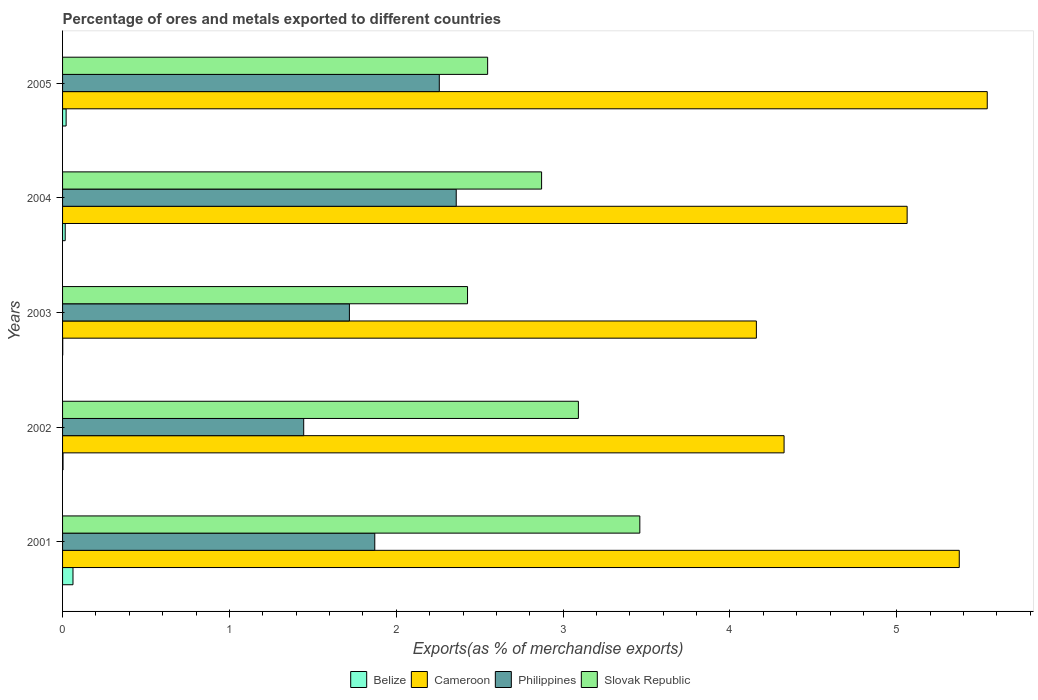How many different coloured bars are there?
Your answer should be very brief. 4. Are the number of bars per tick equal to the number of legend labels?
Provide a short and direct response. Yes. Are the number of bars on each tick of the Y-axis equal?
Your response must be concise. Yes. How many bars are there on the 5th tick from the top?
Ensure brevity in your answer.  4. What is the label of the 3rd group of bars from the top?
Offer a terse response. 2003. In how many cases, is the number of bars for a given year not equal to the number of legend labels?
Keep it short and to the point. 0. What is the percentage of exports to different countries in Cameroon in 2001?
Provide a short and direct response. 5.37. Across all years, what is the maximum percentage of exports to different countries in Philippines?
Your answer should be compact. 2.36. Across all years, what is the minimum percentage of exports to different countries in Cameroon?
Ensure brevity in your answer.  4.16. In which year was the percentage of exports to different countries in Philippines maximum?
Keep it short and to the point. 2004. What is the total percentage of exports to different countries in Philippines in the graph?
Provide a succinct answer. 9.65. What is the difference between the percentage of exports to different countries in Cameroon in 2001 and that in 2004?
Your answer should be compact. 0.31. What is the difference between the percentage of exports to different countries in Cameroon in 2004 and the percentage of exports to different countries in Philippines in 2001?
Offer a terse response. 3.19. What is the average percentage of exports to different countries in Cameroon per year?
Offer a terse response. 4.89. In the year 2004, what is the difference between the percentage of exports to different countries in Philippines and percentage of exports to different countries in Slovak Republic?
Offer a terse response. -0.51. In how many years, is the percentage of exports to different countries in Belize greater than 1.2 %?
Your response must be concise. 0. What is the ratio of the percentage of exports to different countries in Slovak Republic in 2001 to that in 2002?
Your answer should be very brief. 1.12. What is the difference between the highest and the second highest percentage of exports to different countries in Cameroon?
Ensure brevity in your answer.  0.17. What is the difference between the highest and the lowest percentage of exports to different countries in Belize?
Give a very brief answer. 0.06. In how many years, is the percentage of exports to different countries in Slovak Republic greater than the average percentage of exports to different countries in Slovak Republic taken over all years?
Make the answer very short. 2. Is it the case that in every year, the sum of the percentage of exports to different countries in Philippines and percentage of exports to different countries in Cameroon is greater than the sum of percentage of exports to different countries in Slovak Republic and percentage of exports to different countries in Belize?
Offer a terse response. No. What does the 4th bar from the top in 2005 represents?
Provide a succinct answer. Belize. What does the 3rd bar from the bottom in 2005 represents?
Provide a succinct answer. Philippines. Is it the case that in every year, the sum of the percentage of exports to different countries in Cameroon and percentage of exports to different countries in Philippines is greater than the percentage of exports to different countries in Slovak Republic?
Offer a terse response. Yes. Are all the bars in the graph horizontal?
Offer a terse response. Yes. How many years are there in the graph?
Make the answer very short. 5. What is the difference between two consecutive major ticks on the X-axis?
Offer a very short reply. 1. Does the graph contain any zero values?
Ensure brevity in your answer.  No. Where does the legend appear in the graph?
Ensure brevity in your answer.  Bottom center. How many legend labels are there?
Your answer should be compact. 4. How are the legend labels stacked?
Keep it short and to the point. Horizontal. What is the title of the graph?
Make the answer very short. Percentage of ores and metals exported to different countries. What is the label or title of the X-axis?
Give a very brief answer. Exports(as % of merchandise exports). What is the label or title of the Y-axis?
Give a very brief answer. Years. What is the Exports(as % of merchandise exports) in Belize in 2001?
Your response must be concise. 0.06. What is the Exports(as % of merchandise exports) of Cameroon in 2001?
Keep it short and to the point. 5.37. What is the Exports(as % of merchandise exports) of Philippines in 2001?
Give a very brief answer. 1.87. What is the Exports(as % of merchandise exports) of Slovak Republic in 2001?
Your response must be concise. 3.46. What is the Exports(as % of merchandise exports) of Belize in 2002?
Ensure brevity in your answer.  0. What is the Exports(as % of merchandise exports) of Cameroon in 2002?
Make the answer very short. 4.32. What is the Exports(as % of merchandise exports) of Philippines in 2002?
Offer a terse response. 1.45. What is the Exports(as % of merchandise exports) of Slovak Republic in 2002?
Your answer should be very brief. 3.09. What is the Exports(as % of merchandise exports) in Belize in 2003?
Ensure brevity in your answer.  0. What is the Exports(as % of merchandise exports) of Cameroon in 2003?
Give a very brief answer. 4.16. What is the Exports(as % of merchandise exports) in Philippines in 2003?
Your answer should be very brief. 1.72. What is the Exports(as % of merchandise exports) of Slovak Republic in 2003?
Offer a very short reply. 2.43. What is the Exports(as % of merchandise exports) of Belize in 2004?
Your response must be concise. 0.02. What is the Exports(as % of merchandise exports) in Cameroon in 2004?
Your answer should be very brief. 5.06. What is the Exports(as % of merchandise exports) of Philippines in 2004?
Offer a terse response. 2.36. What is the Exports(as % of merchandise exports) of Slovak Republic in 2004?
Offer a very short reply. 2.87. What is the Exports(as % of merchandise exports) of Belize in 2005?
Make the answer very short. 0.02. What is the Exports(as % of merchandise exports) of Cameroon in 2005?
Offer a very short reply. 5.54. What is the Exports(as % of merchandise exports) in Philippines in 2005?
Provide a short and direct response. 2.26. What is the Exports(as % of merchandise exports) in Slovak Republic in 2005?
Offer a very short reply. 2.55. Across all years, what is the maximum Exports(as % of merchandise exports) in Belize?
Ensure brevity in your answer.  0.06. Across all years, what is the maximum Exports(as % of merchandise exports) of Cameroon?
Keep it short and to the point. 5.54. Across all years, what is the maximum Exports(as % of merchandise exports) of Philippines?
Provide a short and direct response. 2.36. Across all years, what is the maximum Exports(as % of merchandise exports) in Slovak Republic?
Make the answer very short. 3.46. Across all years, what is the minimum Exports(as % of merchandise exports) in Belize?
Provide a short and direct response. 0. Across all years, what is the minimum Exports(as % of merchandise exports) in Cameroon?
Give a very brief answer. 4.16. Across all years, what is the minimum Exports(as % of merchandise exports) of Philippines?
Your answer should be compact. 1.45. Across all years, what is the minimum Exports(as % of merchandise exports) of Slovak Republic?
Give a very brief answer. 2.43. What is the total Exports(as % of merchandise exports) in Belize in the graph?
Offer a very short reply. 0.1. What is the total Exports(as % of merchandise exports) of Cameroon in the graph?
Your answer should be very brief. 24.46. What is the total Exports(as % of merchandise exports) of Philippines in the graph?
Provide a succinct answer. 9.65. What is the total Exports(as % of merchandise exports) in Slovak Republic in the graph?
Your answer should be very brief. 14.4. What is the difference between the Exports(as % of merchandise exports) in Belize in 2001 and that in 2002?
Offer a terse response. 0.06. What is the difference between the Exports(as % of merchandise exports) in Philippines in 2001 and that in 2002?
Offer a very short reply. 0.43. What is the difference between the Exports(as % of merchandise exports) of Slovak Republic in 2001 and that in 2002?
Offer a terse response. 0.37. What is the difference between the Exports(as % of merchandise exports) of Belize in 2001 and that in 2003?
Offer a terse response. 0.06. What is the difference between the Exports(as % of merchandise exports) of Cameroon in 2001 and that in 2003?
Give a very brief answer. 1.22. What is the difference between the Exports(as % of merchandise exports) of Philippines in 2001 and that in 2003?
Provide a succinct answer. 0.15. What is the difference between the Exports(as % of merchandise exports) of Slovak Republic in 2001 and that in 2003?
Give a very brief answer. 1.03. What is the difference between the Exports(as % of merchandise exports) of Belize in 2001 and that in 2004?
Give a very brief answer. 0.05. What is the difference between the Exports(as % of merchandise exports) in Cameroon in 2001 and that in 2004?
Provide a short and direct response. 0.31. What is the difference between the Exports(as % of merchandise exports) of Philippines in 2001 and that in 2004?
Your response must be concise. -0.49. What is the difference between the Exports(as % of merchandise exports) in Slovak Republic in 2001 and that in 2004?
Your response must be concise. 0.59. What is the difference between the Exports(as % of merchandise exports) in Belize in 2001 and that in 2005?
Provide a short and direct response. 0.04. What is the difference between the Exports(as % of merchandise exports) in Cameroon in 2001 and that in 2005?
Offer a very short reply. -0.17. What is the difference between the Exports(as % of merchandise exports) of Philippines in 2001 and that in 2005?
Make the answer very short. -0.39. What is the difference between the Exports(as % of merchandise exports) of Slovak Republic in 2001 and that in 2005?
Your answer should be compact. 0.91. What is the difference between the Exports(as % of merchandise exports) of Belize in 2002 and that in 2003?
Provide a succinct answer. 0. What is the difference between the Exports(as % of merchandise exports) of Cameroon in 2002 and that in 2003?
Provide a short and direct response. 0.17. What is the difference between the Exports(as % of merchandise exports) of Philippines in 2002 and that in 2003?
Provide a short and direct response. -0.27. What is the difference between the Exports(as % of merchandise exports) of Slovak Republic in 2002 and that in 2003?
Your answer should be very brief. 0.66. What is the difference between the Exports(as % of merchandise exports) of Belize in 2002 and that in 2004?
Your answer should be very brief. -0.01. What is the difference between the Exports(as % of merchandise exports) in Cameroon in 2002 and that in 2004?
Keep it short and to the point. -0.74. What is the difference between the Exports(as % of merchandise exports) of Philippines in 2002 and that in 2004?
Offer a terse response. -0.91. What is the difference between the Exports(as % of merchandise exports) in Slovak Republic in 2002 and that in 2004?
Your response must be concise. 0.22. What is the difference between the Exports(as % of merchandise exports) in Belize in 2002 and that in 2005?
Your response must be concise. -0.02. What is the difference between the Exports(as % of merchandise exports) of Cameroon in 2002 and that in 2005?
Give a very brief answer. -1.22. What is the difference between the Exports(as % of merchandise exports) of Philippines in 2002 and that in 2005?
Offer a very short reply. -0.81. What is the difference between the Exports(as % of merchandise exports) of Slovak Republic in 2002 and that in 2005?
Your response must be concise. 0.54. What is the difference between the Exports(as % of merchandise exports) in Belize in 2003 and that in 2004?
Provide a succinct answer. -0.01. What is the difference between the Exports(as % of merchandise exports) in Cameroon in 2003 and that in 2004?
Your answer should be very brief. -0.9. What is the difference between the Exports(as % of merchandise exports) of Philippines in 2003 and that in 2004?
Your answer should be compact. -0.64. What is the difference between the Exports(as % of merchandise exports) in Slovak Republic in 2003 and that in 2004?
Provide a succinct answer. -0.44. What is the difference between the Exports(as % of merchandise exports) of Belize in 2003 and that in 2005?
Your answer should be compact. -0.02. What is the difference between the Exports(as % of merchandise exports) in Cameroon in 2003 and that in 2005?
Keep it short and to the point. -1.38. What is the difference between the Exports(as % of merchandise exports) in Philippines in 2003 and that in 2005?
Keep it short and to the point. -0.54. What is the difference between the Exports(as % of merchandise exports) of Slovak Republic in 2003 and that in 2005?
Make the answer very short. -0.12. What is the difference between the Exports(as % of merchandise exports) of Belize in 2004 and that in 2005?
Give a very brief answer. -0.01. What is the difference between the Exports(as % of merchandise exports) of Cameroon in 2004 and that in 2005?
Provide a short and direct response. -0.48. What is the difference between the Exports(as % of merchandise exports) of Philippines in 2004 and that in 2005?
Make the answer very short. 0.1. What is the difference between the Exports(as % of merchandise exports) of Slovak Republic in 2004 and that in 2005?
Offer a very short reply. 0.32. What is the difference between the Exports(as % of merchandise exports) of Belize in 2001 and the Exports(as % of merchandise exports) of Cameroon in 2002?
Make the answer very short. -4.26. What is the difference between the Exports(as % of merchandise exports) in Belize in 2001 and the Exports(as % of merchandise exports) in Philippines in 2002?
Your answer should be very brief. -1.38. What is the difference between the Exports(as % of merchandise exports) in Belize in 2001 and the Exports(as % of merchandise exports) in Slovak Republic in 2002?
Offer a very short reply. -3.03. What is the difference between the Exports(as % of merchandise exports) of Cameroon in 2001 and the Exports(as % of merchandise exports) of Philippines in 2002?
Provide a succinct answer. 3.93. What is the difference between the Exports(as % of merchandise exports) of Cameroon in 2001 and the Exports(as % of merchandise exports) of Slovak Republic in 2002?
Give a very brief answer. 2.28. What is the difference between the Exports(as % of merchandise exports) of Philippines in 2001 and the Exports(as % of merchandise exports) of Slovak Republic in 2002?
Ensure brevity in your answer.  -1.22. What is the difference between the Exports(as % of merchandise exports) of Belize in 2001 and the Exports(as % of merchandise exports) of Cameroon in 2003?
Keep it short and to the point. -4.1. What is the difference between the Exports(as % of merchandise exports) of Belize in 2001 and the Exports(as % of merchandise exports) of Philippines in 2003?
Provide a succinct answer. -1.66. What is the difference between the Exports(as % of merchandise exports) in Belize in 2001 and the Exports(as % of merchandise exports) in Slovak Republic in 2003?
Offer a terse response. -2.36. What is the difference between the Exports(as % of merchandise exports) of Cameroon in 2001 and the Exports(as % of merchandise exports) of Philippines in 2003?
Offer a terse response. 3.66. What is the difference between the Exports(as % of merchandise exports) of Cameroon in 2001 and the Exports(as % of merchandise exports) of Slovak Republic in 2003?
Give a very brief answer. 2.95. What is the difference between the Exports(as % of merchandise exports) of Philippines in 2001 and the Exports(as % of merchandise exports) of Slovak Republic in 2003?
Keep it short and to the point. -0.56. What is the difference between the Exports(as % of merchandise exports) of Belize in 2001 and the Exports(as % of merchandise exports) of Cameroon in 2004?
Your answer should be compact. -5. What is the difference between the Exports(as % of merchandise exports) in Belize in 2001 and the Exports(as % of merchandise exports) in Philippines in 2004?
Provide a succinct answer. -2.3. What is the difference between the Exports(as % of merchandise exports) of Belize in 2001 and the Exports(as % of merchandise exports) of Slovak Republic in 2004?
Your response must be concise. -2.81. What is the difference between the Exports(as % of merchandise exports) of Cameroon in 2001 and the Exports(as % of merchandise exports) of Philippines in 2004?
Give a very brief answer. 3.01. What is the difference between the Exports(as % of merchandise exports) of Cameroon in 2001 and the Exports(as % of merchandise exports) of Slovak Republic in 2004?
Your answer should be very brief. 2.5. What is the difference between the Exports(as % of merchandise exports) in Philippines in 2001 and the Exports(as % of merchandise exports) in Slovak Republic in 2004?
Offer a very short reply. -1. What is the difference between the Exports(as % of merchandise exports) in Belize in 2001 and the Exports(as % of merchandise exports) in Cameroon in 2005?
Offer a very short reply. -5.48. What is the difference between the Exports(as % of merchandise exports) in Belize in 2001 and the Exports(as % of merchandise exports) in Philippines in 2005?
Offer a terse response. -2.2. What is the difference between the Exports(as % of merchandise exports) of Belize in 2001 and the Exports(as % of merchandise exports) of Slovak Republic in 2005?
Your response must be concise. -2.49. What is the difference between the Exports(as % of merchandise exports) of Cameroon in 2001 and the Exports(as % of merchandise exports) of Philippines in 2005?
Offer a terse response. 3.12. What is the difference between the Exports(as % of merchandise exports) of Cameroon in 2001 and the Exports(as % of merchandise exports) of Slovak Republic in 2005?
Offer a terse response. 2.83. What is the difference between the Exports(as % of merchandise exports) of Philippines in 2001 and the Exports(as % of merchandise exports) of Slovak Republic in 2005?
Ensure brevity in your answer.  -0.68. What is the difference between the Exports(as % of merchandise exports) in Belize in 2002 and the Exports(as % of merchandise exports) in Cameroon in 2003?
Offer a very short reply. -4.16. What is the difference between the Exports(as % of merchandise exports) in Belize in 2002 and the Exports(as % of merchandise exports) in Philippines in 2003?
Give a very brief answer. -1.72. What is the difference between the Exports(as % of merchandise exports) in Belize in 2002 and the Exports(as % of merchandise exports) in Slovak Republic in 2003?
Keep it short and to the point. -2.42. What is the difference between the Exports(as % of merchandise exports) in Cameroon in 2002 and the Exports(as % of merchandise exports) in Philippines in 2003?
Offer a terse response. 2.61. What is the difference between the Exports(as % of merchandise exports) of Cameroon in 2002 and the Exports(as % of merchandise exports) of Slovak Republic in 2003?
Make the answer very short. 1.9. What is the difference between the Exports(as % of merchandise exports) in Philippines in 2002 and the Exports(as % of merchandise exports) in Slovak Republic in 2003?
Ensure brevity in your answer.  -0.98. What is the difference between the Exports(as % of merchandise exports) in Belize in 2002 and the Exports(as % of merchandise exports) in Cameroon in 2004?
Your answer should be very brief. -5.06. What is the difference between the Exports(as % of merchandise exports) of Belize in 2002 and the Exports(as % of merchandise exports) of Philippines in 2004?
Ensure brevity in your answer.  -2.36. What is the difference between the Exports(as % of merchandise exports) of Belize in 2002 and the Exports(as % of merchandise exports) of Slovak Republic in 2004?
Make the answer very short. -2.87. What is the difference between the Exports(as % of merchandise exports) in Cameroon in 2002 and the Exports(as % of merchandise exports) in Philippines in 2004?
Give a very brief answer. 1.96. What is the difference between the Exports(as % of merchandise exports) in Cameroon in 2002 and the Exports(as % of merchandise exports) in Slovak Republic in 2004?
Offer a very short reply. 1.45. What is the difference between the Exports(as % of merchandise exports) in Philippines in 2002 and the Exports(as % of merchandise exports) in Slovak Republic in 2004?
Your answer should be very brief. -1.43. What is the difference between the Exports(as % of merchandise exports) of Belize in 2002 and the Exports(as % of merchandise exports) of Cameroon in 2005?
Provide a succinct answer. -5.54. What is the difference between the Exports(as % of merchandise exports) in Belize in 2002 and the Exports(as % of merchandise exports) in Philippines in 2005?
Keep it short and to the point. -2.26. What is the difference between the Exports(as % of merchandise exports) in Belize in 2002 and the Exports(as % of merchandise exports) in Slovak Republic in 2005?
Your response must be concise. -2.54. What is the difference between the Exports(as % of merchandise exports) of Cameroon in 2002 and the Exports(as % of merchandise exports) of Philippines in 2005?
Provide a succinct answer. 2.07. What is the difference between the Exports(as % of merchandise exports) of Cameroon in 2002 and the Exports(as % of merchandise exports) of Slovak Republic in 2005?
Offer a terse response. 1.78. What is the difference between the Exports(as % of merchandise exports) of Philippines in 2002 and the Exports(as % of merchandise exports) of Slovak Republic in 2005?
Your answer should be compact. -1.1. What is the difference between the Exports(as % of merchandise exports) of Belize in 2003 and the Exports(as % of merchandise exports) of Cameroon in 2004?
Your answer should be very brief. -5.06. What is the difference between the Exports(as % of merchandise exports) of Belize in 2003 and the Exports(as % of merchandise exports) of Philippines in 2004?
Provide a succinct answer. -2.36. What is the difference between the Exports(as % of merchandise exports) of Belize in 2003 and the Exports(as % of merchandise exports) of Slovak Republic in 2004?
Offer a terse response. -2.87. What is the difference between the Exports(as % of merchandise exports) of Cameroon in 2003 and the Exports(as % of merchandise exports) of Philippines in 2004?
Make the answer very short. 1.8. What is the difference between the Exports(as % of merchandise exports) in Cameroon in 2003 and the Exports(as % of merchandise exports) in Slovak Republic in 2004?
Offer a terse response. 1.29. What is the difference between the Exports(as % of merchandise exports) in Philippines in 2003 and the Exports(as % of merchandise exports) in Slovak Republic in 2004?
Your answer should be very brief. -1.15. What is the difference between the Exports(as % of merchandise exports) of Belize in 2003 and the Exports(as % of merchandise exports) of Cameroon in 2005?
Your response must be concise. -5.54. What is the difference between the Exports(as % of merchandise exports) of Belize in 2003 and the Exports(as % of merchandise exports) of Philippines in 2005?
Offer a terse response. -2.26. What is the difference between the Exports(as % of merchandise exports) of Belize in 2003 and the Exports(as % of merchandise exports) of Slovak Republic in 2005?
Keep it short and to the point. -2.55. What is the difference between the Exports(as % of merchandise exports) of Cameroon in 2003 and the Exports(as % of merchandise exports) of Philippines in 2005?
Your answer should be very brief. 1.9. What is the difference between the Exports(as % of merchandise exports) in Cameroon in 2003 and the Exports(as % of merchandise exports) in Slovak Republic in 2005?
Give a very brief answer. 1.61. What is the difference between the Exports(as % of merchandise exports) of Philippines in 2003 and the Exports(as % of merchandise exports) of Slovak Republic in 2005?
Provide a short and direct response. -0.83. What is the difference between the Exports(as % of merchandise exports) in Belize in 2004 and the Exports(as % of merchandise exports) in Cameroon in 2005?
Your answer should be very brief. -5.53. What is the difference between the Exports(as % of merchandise exports) of Belize in 2004 and the Exports(as % of merchandise exports) of Philippines in 2005?
Make the answer very short. -2.24. What is the difference between the Exports(as % of merchandise exports) of Belize in 2004 and the Exports(as % of merchandise exports) of Slovak Republic in 2005?
Your response must be concise. -2.53. What is the difference between the Exports(as % of merchandise exports) of Cameroon in 2004 and the Exports(as % of merchandise exports) of Philippines in 2005?
Your answer should be very brief. 2.8. What is the difference between the Exports(as % of merchandise exports) of Cameroon in 2004 and the Exports(as % of merchandise exports) of Slovak Republic in 2005?
Offer a very short reply. 2.51. What is the difference between the Exports(as % of merchandise exports) in Philippines in 2004 and the Exports(as % of merchandise exports) in Slovak Republic in 2005?
Offer a very short reply. -0.19. What is the average Exports(as % of merchandise exports) in Belize per year?
Your answer should be very brief. 0.02. What is the average Exports(as % of merchandise exports) in Cameroon per year?
Make the answer very short. 4.89. What is the average Exports(as % of merchandise exports) of Philippines per year?
Provide a short and direct response. 1.93. What is the average Exports(as % of merchandise exports) in Slovak Republic per year?
Keep it short and to the point. 2.88. In the year 2001, what is the difference between the Exports(as % of merchandise exports) in Belize and Exports(as % of merchandise exports) in Cameroon?
Keep it short and to the point. -5.31. In the year 2001, what is the difference between the Exports(as % of merchandise exports) in Belize and Exports(as % of merchandise exports) in Philippines?
Your answer should be compact. -1.81. In the year 2001, what is the difference between the Exports(as % of merchandise exports) of Belize and Exports(as % of merchandise exports) of Slovak Republic?
Keep it short and to the point. -3.4. In the year 2001, what is the difference between the Exports(as % of merchandise exports) of Cameroon and Exports(as % of merchandise exports) of Philippines?
Your answer should be very brief. 3.5. In the year 2001, what is the difference between the Exports(as % of merchandise exports) in Cameroon and Exports(as % of merchandise exports) in Slovak Republic?
Provide a succinct answer. 1.91. In the year 2001, what is the difference between the Exports(as % of merchandise exports) in Philippines and Exports(as % of merchandise exports) in Slovak Republic?
Your answer should be compact. -1.59. In the year 2002, what is the difference between the Exports(as % of merchandise exports) of Belize and Exports(as % of merchandise exports) of Cameroon?
Give a very brief answer. -4.32. In the year 2002, what is the difference between the Exports(as % of merchandise exports) in Belize and Exports(as % of merchandise exports) in Philippines?
Offer a very short reply. -1.44. In the year 2002, what is the difference between the Exports(as % of merchandise exports) of Belize and Exports(as % of merchandise exports) of Slovak Republic?
Make the answer very short. -3.09. In the year 2002, what is the difference between the Exports(as % of merchandise exports) in Cameroon and Exports(as % of merchandise exports) in Philippines?
Offer a terse response. 2.88. In the year 2002, what is the difference between the Exports(as % of merchandise exports) in Cameroon and Exports(as % of merchandise exports) in Slovak Republic?
Offer a very short reply. 1.23. In the year 2002, what is the difference between the Exports(as % of merchandise exports) of Philippines and Exports(as % of merchandise exports) of Slovak Republic?
Your response must be concise. -1.65. In the year 2003, what is the difference between the Exports(as % of merchandise exports) of Belize and Exports(as % of merchandise exports) of Cameroon?
Your answer should be compact. -4.16. In the year 2003, what is the difference between the Exports(as % of merchandise exports) of Belize and Exports(as % of merchandise exports) of Philippines?
Your answer should be very brief. -1.72. In the year 2003, what is the difference between the Exports(as % of merchandise exports) in Belize and Exports(as % of merchandise exports) in Slovak Republic?
Provide a short and direct response. -2.43. In the year 2003, what is the difference between the Exports(as % of merchandise exports) of Cameroon and Exports(as % of merchandise exports) of Philippines?
Make the answer very short. 2.44. In the year 2003, what is the difference between the Exports(as % of merchandise exports) in Cameroon and Exports(as % of merchandise exports) in Slovak Republic?
Ensure brevity in your answer.  1.73. In the year 2003, what is the difference between the Exports(as % of merchandise exports) in Philippines and Exports(as % of merchandise exports) in Slovak Republic?
Offer a very short reply. -0.71. In the year 2004, what is the difference between the Exports(as % of merchandise exports) in Belize and Exports(as % of merchandise exports) in Cameroon?
Provide a succinct answer. -5.05. In the year 2004, what is the difference between the Exports(as % of merchandise exports) in Belize and Exports(as % of merchandise exports) in Philippines?
Provide a short and direct response. -2.34. In the year 2004, what is the difference between the Exports(as % of merchandise exports) in Belize and Exports(as % of merchandise exports) in Slovak Republic?
Offer a very short reply. -2.86. In the year 2004, what is the difference between the Exports(as % of merchandise exports) in Cameroon and Exports(as % of merchandise exports) in Philippines?
Provide a short and direct response. 2.7. In the year 2004, what is the difference between the Exports(as % of merchandise exports) in Cameroon and Exports(as % of merchandise exports) in Slovak Republic?
Your answer should be very brief. 2.19. In the year 2004, what is the difference between the Exports(as % of merchandise exports) in Philippines and Exports(as % of merchandise exports) in Slovak Republic?
Make the answer very short. -0.51. In the year 2005, what is the difference between the Exports(as % of merchandise exports) of Belize and Exports(as % of merchandise exports) of Cameroon?
Your response must be concise. -5.52. In the year 2005, what is the difference between the Exports(as % of merchandise exports) in Belize and Exports(as % of merchandise exports) in Philippines?
Keep it short and to the point. -2.24. In the year 2005, what is the difference between the Exports(as % of merchandise exports) of Belize and Exports(as % of merchandise exports) of Slovak Republic?
Your answer should be very brief. -2.53. In the year 2005, what is the difference between the Exports(as % of merchandise exports) of Cameroon and Exports(as % of merchandise exports) of Philippines?
Offer a terse response. 3.28. In the year 2005, what is the difference between the Exports(as % of merchandise exports) of Cameroon and Exports(as % of merchandise exports) of Slovak Republic?
Offer a terse response. 2.99. In the year 2005, what is the difference between the Exports(as % of merchandise exports) in Philippines and Exports(as % of merchandise exports) in Slovak Republic?
Offer a terse response. -0.29. What is the ratio of the Exports(as % of merchandise exports) in Belize in 2001 to that in 2002?
Your response must be concise. 22.6. What is the ratio of the Exports(as % of merchandise exports) of Cameroon in 2001 to that in 2002?
Give a very brief answer. 1.24. What is the ratio of the Exports(as % of merchandise exports) in Philippines in 2001 to that in 2002?
Make the answer very short. 1.29. What is the ratio of the Exports(as % of merchandise exports) of Slovak Republic in 2001 to that in 2002?
Ensure brevity in your answer.  1.12. What is the ratio of the Exports(as % of merchandise exports) of Belize in 2001 to that in 2003?
Make the answer very short. 64.6. What is the ratio of the Exports(as % of merchandise exports) of Cameroon in 2001 to that in 2003?
Offer a very short reply. 1.29. What is the ratio of the Exports(as % of merchandise exports) in Philippines in 2001 to that in 2003?
Offer a very short reply. 1.09. What is the ratio of the Exports(as % of merchandise exports) in Slovak Republic in 2001 to that in 2003?
Offer a very short reply. 1.43. What is the ratio of the Exports(as % of merchandise exports) of Belize in 2001 to that in 2004?
Keep it short and to the point. 3.95. What is the ratio of the Exports(as % of merchandise exports) in Cameroon in 2001 to that in 2004?
Your answer should be very brief. 1.06. What is the ratio of the Exports(as % of merchandise exports) of Philippines in 2001 to that in 2004?
Provide a short and direct response. 0.79. What is the ratio of the Exports(as % of merchandise exports) of Slovak Republic in 2001 to that in 2004?
Offer a very short reply. 1.21. What is the ratio of the Exports(as % of merchandise exports) of Belize in 2001 to that in 2005?
Ensure brevity in your answer.  2.92. What is the ratio of the Exports(as % of merchandise exports) of Cameroon in 2001 to that in 2005?
Make the answer very short. 0.97. What is the ratio of the Exports(as % of merchandise exports) of Philippines in 2001 to that in 2005?
Keep it short and to the point. 0.83. What is the ratio of the Exports(as % of merchandise exports) in Slovak Republic in 2001 to that in 2005?
Provide a short and direct response. 1.36. What is the ratio of the Exports(as % of merchandise exports) in Belize in 2002 to that in 2003?
Your answer should be compact. 2.86. What is the ratio of the Exports(as % of merchandise exports) of Cameroon in 2002 to that in 2003?
Provide a succinct answer. 1.04. What is the ratio of the Exports(as % of merchandise exports) in Philippines in 2002 to that in 2003?
Offer a very short reply. 0.84. What is the ratio of the Exports(as % of merchandise exports) in Slovak Republic in 2002 to that in 2003?
Offer a terse response. 1.27. What is the ratio of the Exports(as % of merchandise exports) in Belize in 2002 to that in 2004?
Offer a very short reply. 0.17. What is the ratio of the Exports(as % of merchandise exports) in Cameroon in 2002 to that in 2004?
Ensure brevity in your answer.  0.85. What is the ratio of the Exports(as % of merchandise exports) in Philippines in 2002 to that in 2004?
Your response must be concise. 0.61. What is the ratio of the Exports(as % of merchandise exports) of Slovak Republic in 2002 to that in 2004?
Your answer should be very brief. 1.08. What is the ratio of the Exports(as % of merchandise exports) of Belize in 2002 to that in 2005?
Give a very brief answer. 0.13. What is the ratio of the Exports(as % of merchandise exports) in Cameroon in 2002 to that in 2005?
Your answer should be compact. 0.78. What is the ratio of the Exports(as % of merchandise exports) in Philippines in 2002 to that in 2005?
Offer a very short reply. 0.64. What is the ratio of the Exports(as % of merchandise exports) in Slovak Republic in 2002 to that in 2005?
Give a very brief answer. 1.21. What is the ratio of the Exports(as % of merchandise exports) in Belize in 2003 to that in 2004?
Provide a succinct answer. 0.06. What is the ratio of the Exports(as % of merchandise exports) in Cameroon in 2003 to that in 2004?
Ensure brevity in your answer.  0.82. What is the ratio of the Exports(as % of merchandise exports) in Philippines in 2003 to that in 2004?
Your answer should be very brief. 0.73. What is the ratio of the Exports(as % of merchandise exports) in Slovak Republic in 2003 to that in 2004?
Offer a very short reply. 0.85. What is the ratio of the Exports(as % of merchandise exports) of Belize in 2003 to that in 2005?
Make the answer very short. 0.05. What is the ratio of the Exports(as % of merchandise exports) of Cameroon in 2003 to that in 2005?
Keep it short and to the point. 0.75. What is the ratio of the Exports(as % of merchandise exports) of Philippines in 2003 to that in 2005?
Make the answer very short. 0.76. What is the ratio of the Exports(as % of merchandise exports) in Slovak Republic in 2003 to that in 2005?
Your answer should be compact. 0.95. What is the ratio of the Exports(as % of merchandise exports) in Belize in 2004 to that in 2005?
Provide a short and direct response. 0.74. What is the ratio of the Exports(as % of merchandise exports) in Cameroon in 2004 to that in 2005?
Provide a short and direct response. 0.91. What is the ratio of the Exports(as % of merchandise exports) of Philippines in 2004 to that in 2005?
Provide a short and direct response. 1.04. What is the ratio of the Exports(as % of merchandise exports) in Slovak Republic in 2004 to that in 2005?
Your answer should be very brief. 1.13. What is the difference between the highest and the second highest Exports(as % of merchandise exports) of Belize?
Offer a terse response. 0.04. What is the difference between the highest and the second highest Exports(as % of merchandise exports) in Cameroon?
Your answer should be very brief. 0.17. What is the difference between the highest and the second highest Exports(as % of merchandise exports) in Philippines?
Your response must be concise. 0.1. What is the difference between the highest and the second highest Exports(as % of merchandise exports) in Slovak Republic?
Ensure brevity in your answer.  0.37. What is the difference between the highest and the lowest Exports(as % of merchandise exports) in Belize?
Offer a terse response. 0.06. What is the difference between the highest and the lowest Exports(as % of merchandise exports) of Cameroon?
Offer a terse response. 1.38. What is the difference between the highest and the lowest Exports(as % of merchandise exports) of Philippines?
Ensure brevity in your answer.  0.91. What is the difference between the highest and the lowest Exports(as % of merchandise exports) in Slovak Republic?
Provide a succinct answer. 1.03. 